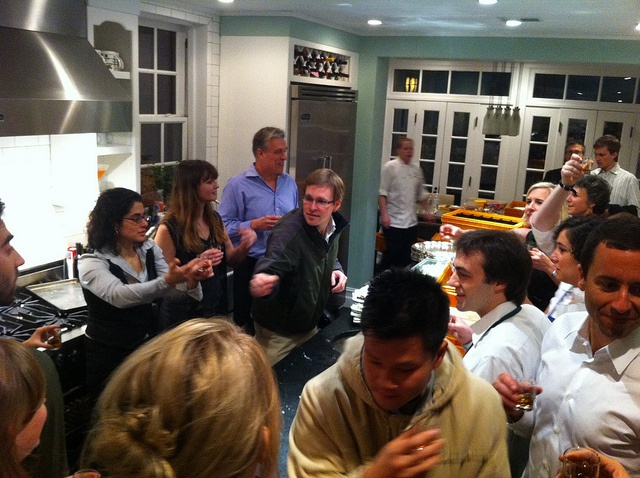Describe the objects in this image and their specific colors. I can see people in black, white, gray, and maroon tones, people in black, maroon, and olive tones, people in black, maroon, and gray tones, people in black, lightgray, maroon, and gray tones, and people in black, darkgray, gray, and maroon tones in this image. 